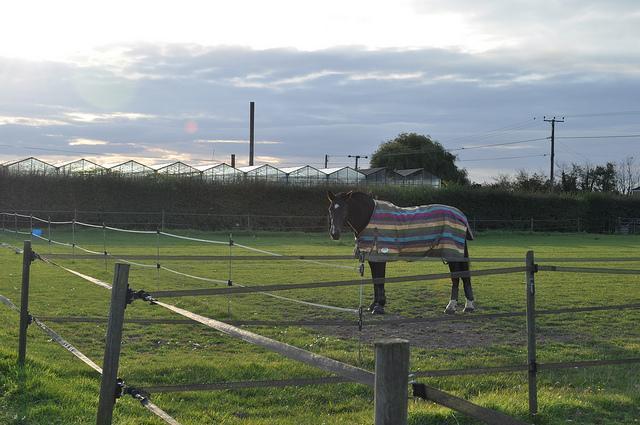How many horses are there?
Give a very brief answer. 1. 